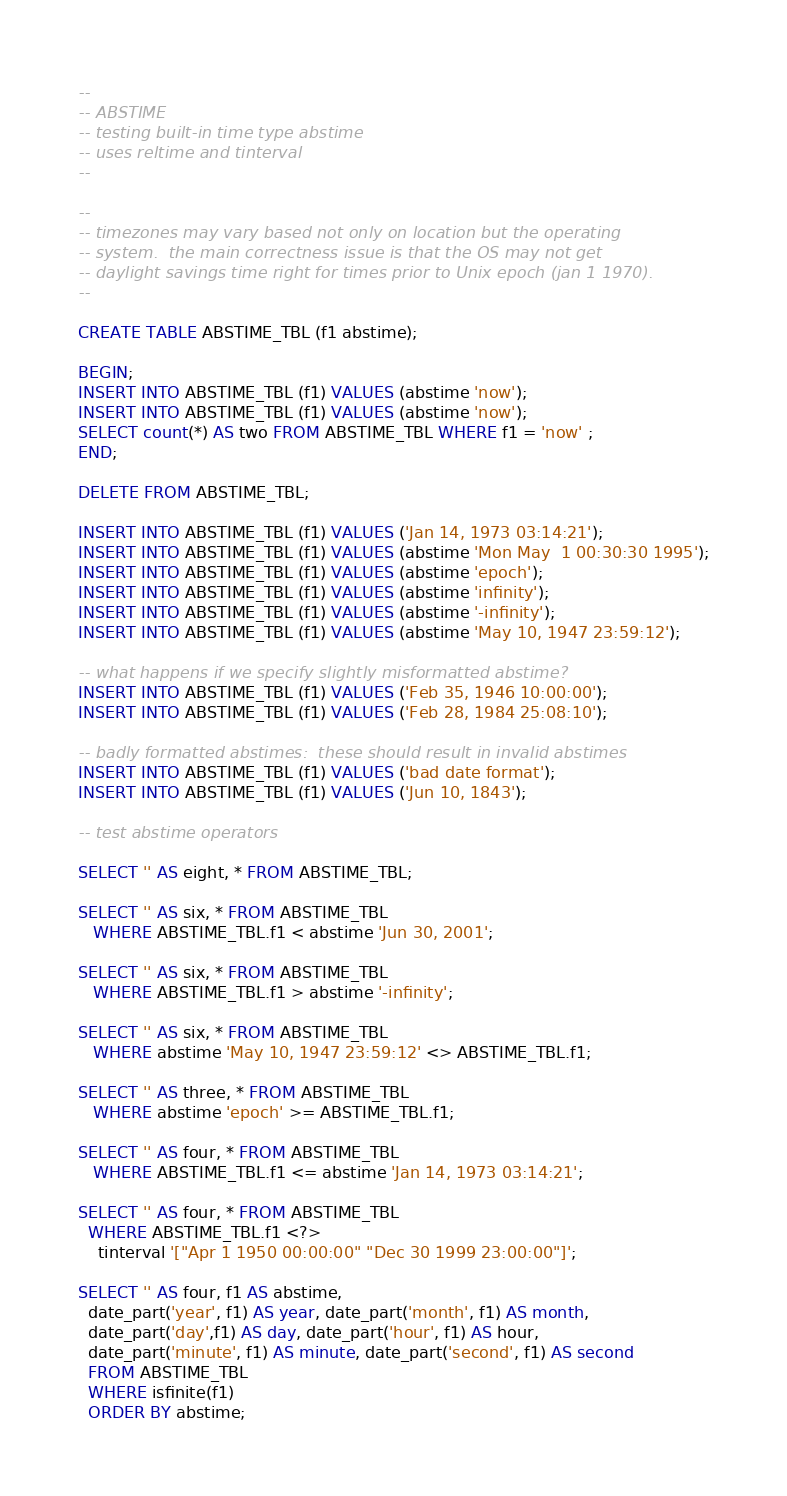<code> <loc_0><loc_0><loc_500><loc_500><_SQL_>--
-- ABSTIME
-- testing built-in time type abstime
-- uses reltime and tinterval
--

--
-- timezones may vary based not only on location but the operating
-- system.  the main correctness issue is that the OS may not get
-- daylight savings time right for times prior to Unix epoch (jan 1 1970).
--

CREATE TABLE ABSTIME_TBL (f1 abstime);

BEGIN;
INSERT INTO ABSTIME_TBL (f1) VALUES (abstime 'now');
INSERT INTO ABSTIME_TBL (f1) VALUES (abstime 'now');
SELECT count(*) AS two FROM ABSTIME_TBL WHERE f1 = 'now' ;
END;

DELETE FROM ABSTIME_TBL;

INSERT INTO ABSTIME_TBL (f1) VALUES ('Jan 14, 1973 03:14:21');
INSERT INTO ABSTIME_TBL (f1) VALUES (abstime 'Mon May  1 00:30:30 1995');
INSERT INTO ABSTIME_TBL (f1) VALUES (abstime 'epoch');
INSERT INTO ABSTIME_TBL (f1) VALUES (abstime 'infinity');
INSERT INTO ABSTIME_TBL (f1) VALUES (abstime '-infinity');
INSERT INTO ABSTIME_TBL (f1) VALUES (abstime 'May 10, 1947 23:59:12');

-- what happens if we specify slightly misformatted abstime?
INSERT INTO ABSTIME_TBL (f1) VALUES ('Feb 35, 1946 10:00:00');
INSERT INTO ABSTIME_TBL (f1) VALUES ('Feb 28, 1984 25:08:10');

-- badly formatted abstimes:  these should result in invalid abstimes
INSERT INTO ABSTIME_TBL (f1) VALUES ('bad date format');
INSERT INTO ABSTIME_TBL (f1) VALUES ('Jun 10, 1843');

-- test abstime operators

SELECT '' AS eight, * FROM ABSTIME_TBL;

SELECT '' AS six, * FROM ABSTIME_TBL
   WHERE ABSTIME_TBL.f1 < abstime 'Jun 30, 2001';

SELECT '' AS six, * FROM ABSTIME_TBL
   WHERE ABSTIME_TBL.f1 > abstime '-infinity';

SELECT '' AS six, * FROM ABSTIME_TBL
   WHERE abstime 'May 10, 1947 23:59:12' <> ABSTIME_TBL.f1;

SELECT '' AS three, * FROM ABSTIME_TBL
   WHERE abstime 'epoch' >= ABSTIME_TBL.f1;

SELECT '' AS four, * FROM ABSTIME_TBL
   WHERE ABSTIME_TBL.f1 <= abstime 'Jan 14, 1973 03:14:21';

SELECT '' AS four, * FROM ABSTIME_TBL
  WHERE ABSTIME_TBL.f1 <?>
	tinterval '["Apr 1 1950 00:00:00" "Dec 30 1999 23:00:00"]';

SELECT '' AS four, f1 AS abstime,
  date_part('year', f1) AS year, date_part('month', f1) AS month,
  date_part('day',f1) AS day, date_part('hour', f1) AS hour,
  date_part('minute', f1) AS minute, date_part('second', f1) AS second
  FROM ABSTIME_TBL
  WHERE isfinite(f1)
  ORDER BY abstime;
</code> 